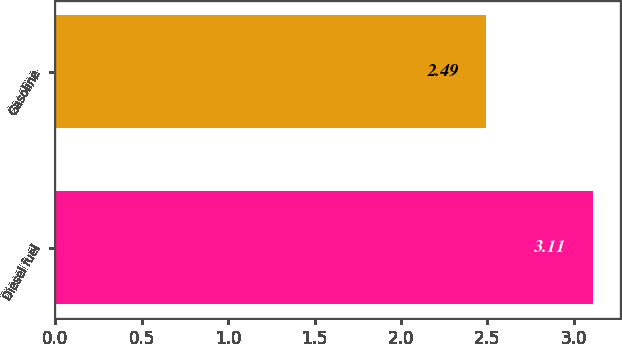Convert chart. <chart><loc_0><loc_0><loc_500><loc_500><bar_chart><fcel>Diesel fuel<fcel>Gasoline<nl><fcel>3.11<fcel>2.49<nl></chart> 